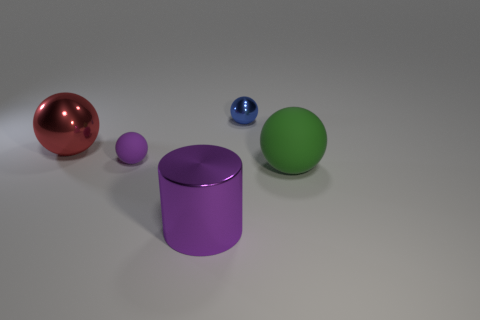Is the number of tiny purple matte objects behind the big purple metal object the same as the number of large purple metal objects behind the green thing?
Make the answer very short. No. What material is the purple thing that is the same shape as the small blue metal object?
Your response must be concise. Rubber. There is a big metal object that is in front of the big ball right of the shiny sphere that is to the right of the small purple thing; what is its shape?
Make the answer very short. Cylinder. Are there more red balls left of the big red thing than tiny green matte balls?
Provide a succinct answer. No. Is the shape of the purple thing that is behind the big purple metallic cylinder the same as  the small metallic thing?
Your response must be concise. Yes. There is a big sphere in front of the red object; what material is it?
Offer a terse response. Rubber. What number of tiny matte objects are the same shape as the red shiny thing?
Ensure brevity in your answer.  1. What material is the tiny thing behind the tiny sphere that is in front of the small blue metallic ball?
Give a very brief answer. Metal. The tiny object that is the same color as the big cylinder is what shape?
Your answer should be compact. Sphere. Is there a purple thing that has the same material as the red sphere?
Your response must be concise. Yes. 